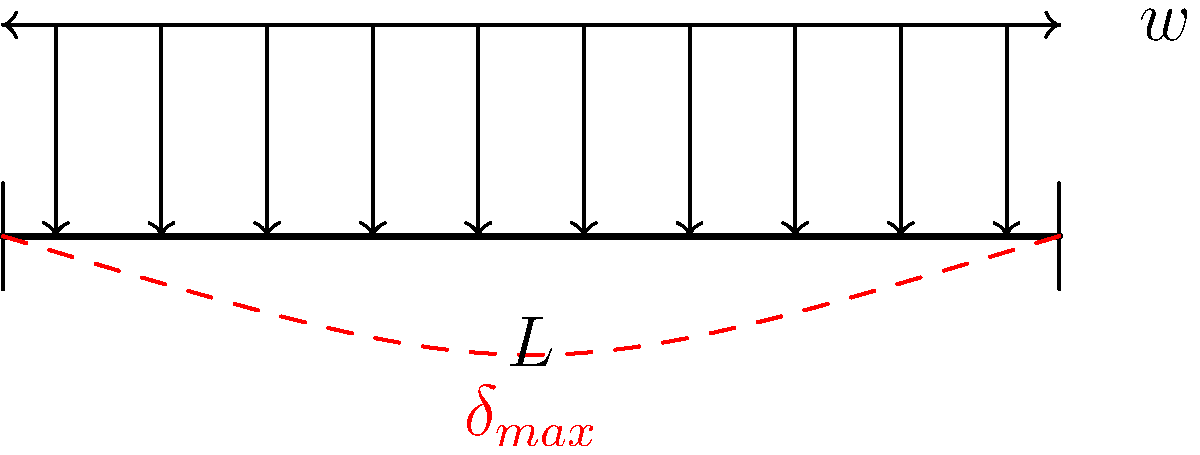In your artistic journey inspired by Gunnar Brynolf Wennerberg, you encounter a problem related to structural design. Consider a simply supported beam of length $L$ subjected to a uniformly distributed load $w$ per unit length. What is the maximum deflection $\delta_{max}$ at the center of the beam in terms of $w$, $L$, $E$ (Young's modulus), and $I$ (moment of inertia)? To find the maximum deflection of a simply supported beam under uniformly distributed load, we can follow these steps:

1. Recall the general equation for the maximum deflection of a simply supported beam under uniformly distributed load:

   $$\delta_{max} = \frac{5wL^4}{384EI}$$

   Where:
   - $\delta_{max}$ is the maximum deflection at the center of the beam
   - $w$ is the uniformly distributed load per unit length
   - $L$ is the length of the beam
   - $E$ is Young's modulus of the material
   - $I$ is the moment of inertia of the beam's cross-section

2. This equation already gives us the maximum deflection in terms of $w$, $L$, $E$, and $I$, so no further manipulation is needed.

3. It's important to note that this deflection occurs at the center of the beam, as shown by the red dashed line in the diagram.

4. The negative sign is often omitted in this equation, as it merely indicates that the deflection is downward.

This equation is crucial in structural design, as it helps ensure that the deflection of beams in structures (like buildings or bridges) remains within acceptable limits, balancing aesthetics with safety and functionality.
Answer: $$\delta_{max} = \frac{5wL^4}{384EI}$$ 